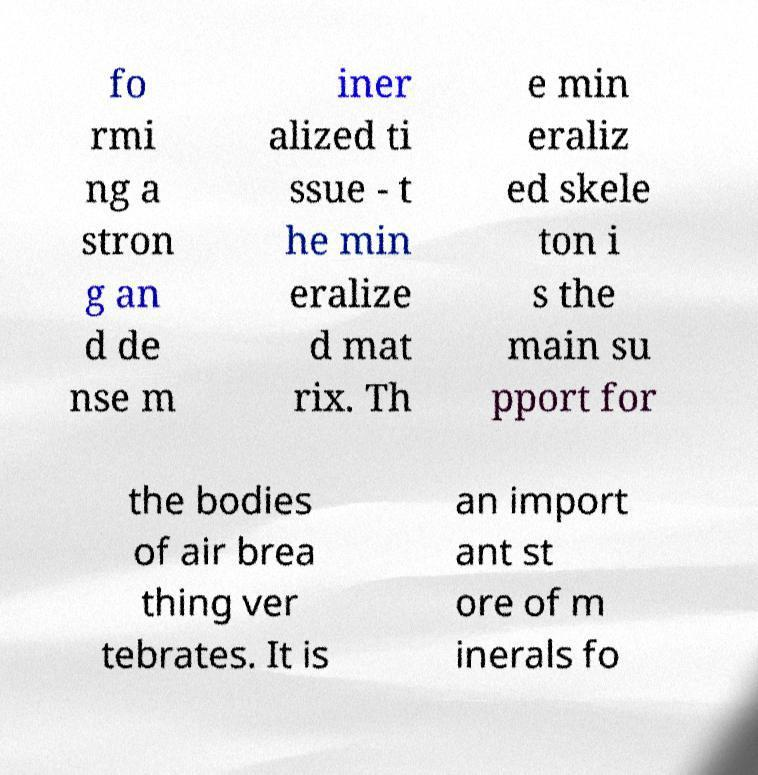Please identify and transcribe the text found in this image. fo rmi ng a stron g an d de nse m iner alized ti ssue - t he min eralize d mat rix. Th e min eraliz ed skele ton i s the main su pport for the bodies of air brea thing ver tebrates. It is an import ant st ore of m inerals fo 